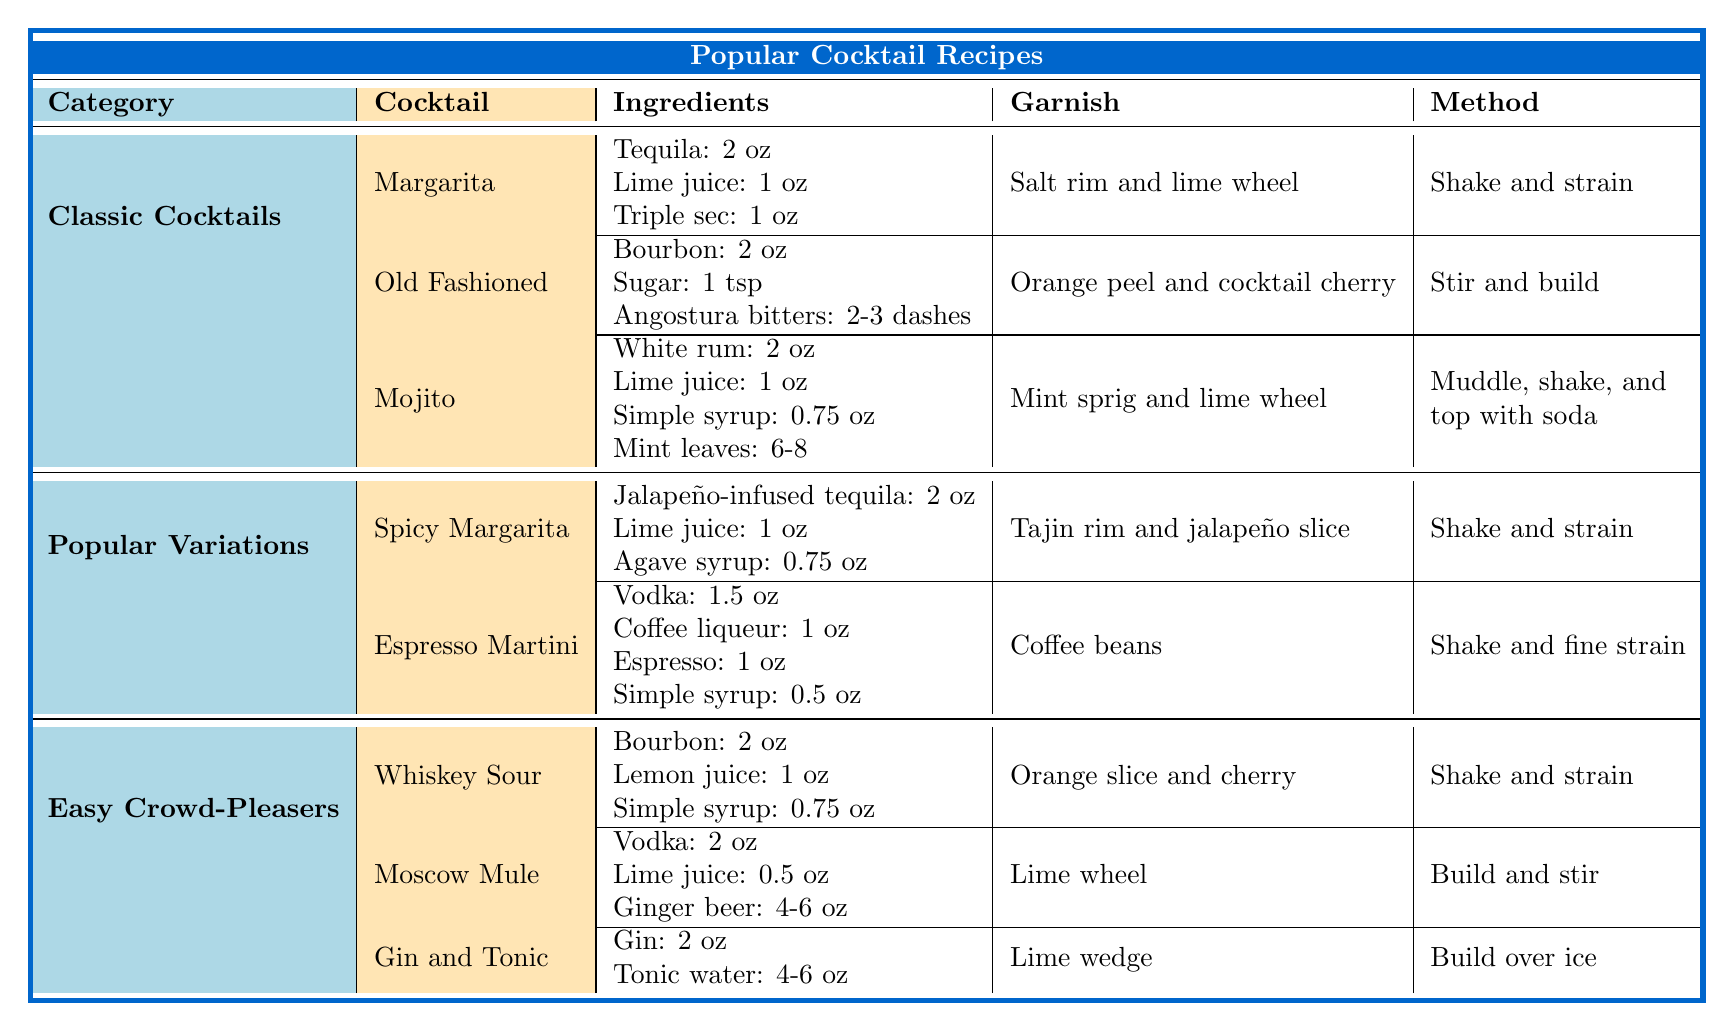What cocktail requires 2 oz of tequila? By looking under the "Classic Cocktails" category, the "Margarita" lists "Tequila: 2 oz" as one of its ingredients.
Answer: Margarita What is the garnish for the Old Fashioned? The Old Fashioned is listed with the garnish "Orange peel and cocktail cherry" under the "Classic Cocktails" section.
Answer: Orange peel and cocktail cherry How many ingredients are used in a Mojito? The Mojito recipe includes four ingredients: "White rum, Lime juice, Simple syrup, and Mint leaves," as listed in the table.
Answer: 4 Which cocktail has a Tajin rim for its garnish? The "Spicy Margarita" listed under "Popular Variations" includes "Tajin rim" as its garnish.
Answer: Spicy Margarita Is the glass for a Whiskey Sour a Margarita glass? The Whiskey Sour is served in a "Rocks glass," not a Margarita glass.
Answer: No What is the method for preparing a Moscow Mule? The method listed for Moscow Mule is "Build and stir," which indicates how to make it.
Answer: Build and stir Which cocktail has the most ingredients? The Mojito and Espresso Martini both have four ingredients listed, making them the cocktails with the most ingredients.
Answer: Mojito and Espresso Martini What is the total amount of lime juice used in both a Margarita and a Mojito? The Margarita uses 1 oz of lime juice and the Mojito uses 1 oz as well. Adding them together gives 1 oz + 1 oz = 2 oz total.
Answer: 2 oz Does the Gin and Tonic require any simple syrup? The Gin and Tonic recipe does not mention simple syrup as one of its ingredients.
Answer: No Which cocktail has coffee beans as its garnish? The "Espresso Martini" has "Coffee beans" listed as its garnish in the table.
Answer: Espresso Martini What is the main spirit used in a Whiskey Sour? The main spirit ingredient for the Whiskey Sour is "Bourbon," as noted in its ingredient list.
Answer: Bourbon 